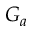<formula> <loc_0><loc_0><loc_500><loc_500>G _ { a }</formula> 